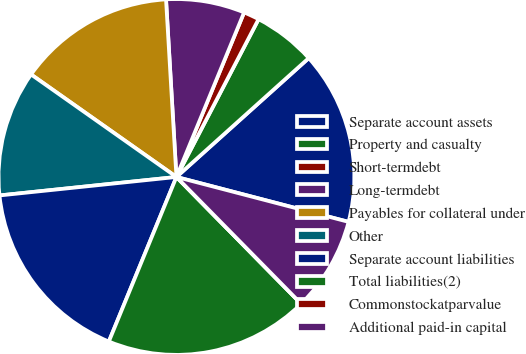<chart> <loc_0><loc_0><loc_500><loc_500><pie_chart><fcel>Separate account assets<fcel>Property and casualty<fcel>Short-termdebt<fcel>Long-termdebt<fcel>Payables for collateral under<fcel>Other<fcel>Separate account liabilities<fcel>Total liabilities(2)<fcel>Commonstockatparvalue<fcel>Additional paid-in capital<nl><fcel>15.71%<fcel>5.71%<fcel>1.43%<fcel>7.14%<fcel>14.29%<fcel>11.43%<fcel>17.14%<fcel>18.57%<fcel>0.0%<fcel>8.57%<nl></chart> 